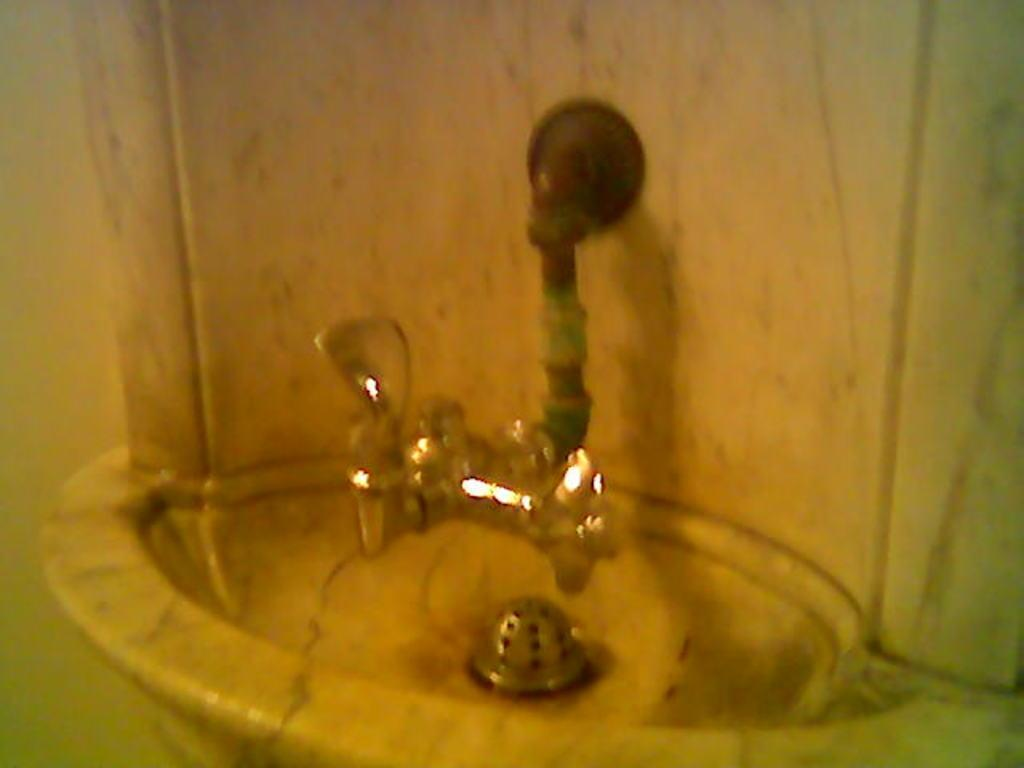What is located in the foreground of the image? There is a sink and a tap in the foreground of the image. What is the sink and tap attached to in the image? The sink and tap are attached to a stone wall. Can you see a robin perched on the tap in the image? There is no robin present in the image. What type of authority figure can be seen in the image? There is no authority figure present in the image. Is there a maid cleaning the sink in the image? There is no maid present in the image. 